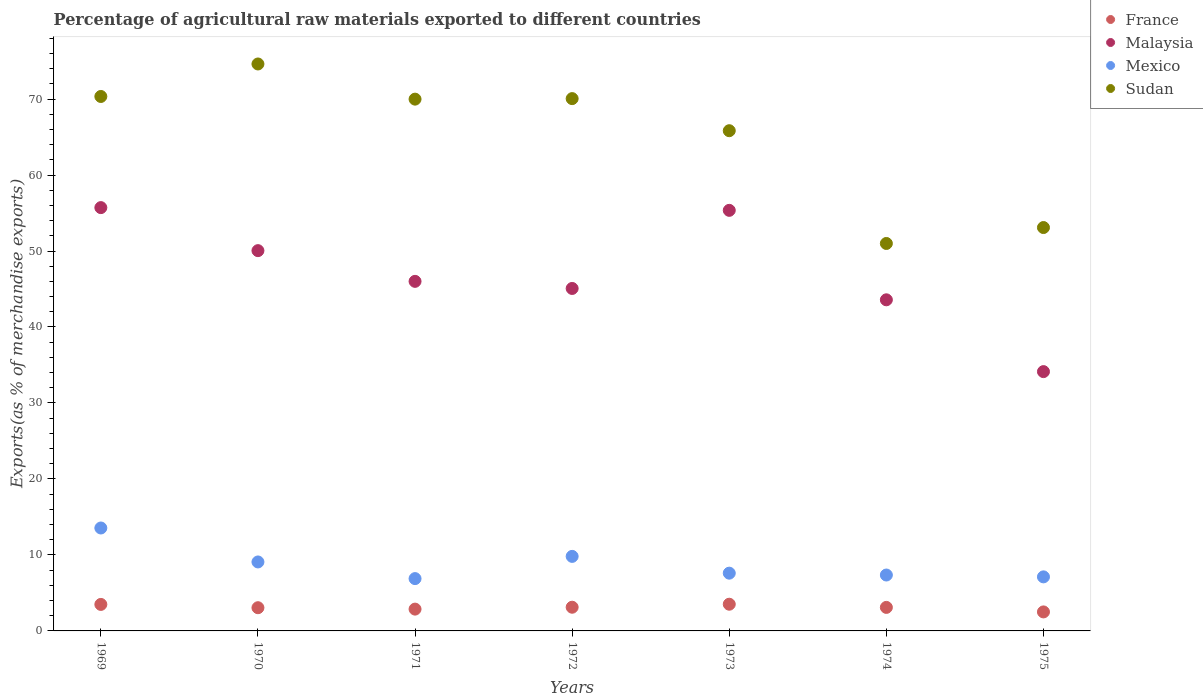How many different coloured dotlines are there?
Make the answer very short. 4. What is the percentage of exports to different countries in Mexico in 1975?
Offer a terse response. 7.11. Across all years, what is the maximum percentage of exports to different countries in France?
Keep it short and to the point. 3.51. Across all years, what is the minimum percentage of exports to different countries in Mexico?
Provide a short and direct response. 6.89. In which year was the percentage of exports to different countries in France maximum?
Provide a short and direct response. 1973. In which year was the percentage of exports to different countries in Malaysia minimum?
Make the answer very short. 1975. What is the total percentage of exports to different countries in France in the graph?
Your answer should be compact. 21.64. What is the difference between the percentage of exports to different countries in Sudan in 1969 and that in 1973?
Offer a very short reply. 4.5. What is the difference between the percentage of exports to different countries in Malaysia in 1971 and the percentage of exports to different countries in France in 1975?
Give a very brief answer. 43.5. What is the average percentage of exports to different countries in Mexico per year?
Offer a very short reply. 8.77. In the year 1969, what is the difference between the percentage of exports to different countries in France and percentage of exports to different countries in Malaysia?
Your answer should be very brief. -52.22. What is the ratio of the percentage of exports to different countries in Sudan in 1973 to that in 1975?
Offer a very short reply. 1.24. Is the percentage of exports to different countries in Mexico in 1970 less than that in 1975?
Provide a short and direct response. No. Is the difference between the percentage of exports to different countries in France in 1970 and 1973 greater than the difference between the percentage of exports to different countries in Malaysia in 1970 and 1973?
Offer a terse response. Yes. What is the difference between the highest and the second highest percentage of exports to different countries in Mexico?
Your answer should be compact. 3.74. What is the difference between the highest and the lowest percentage of exports to different countries in Malaysia?
Your answer should be very brief. 21.58. In how many years, is the percentage of exports to different countries in Sudan greater than the average percentage of exports to different countries in Sudan taken over all years?
Provide a short and direct response. 5. Is the sum of the percentage of exports to different countries in Mexico in 1969 and 1975 greater than the maximum percentage of exports to different countries in Sudan across all years?
Your response must be concise. No. Is the percentage of exports to different countries in Malaysia strictly greater than the percentage of exports to different countries in France over the years?
Provide a short and direct response. Yes. How many dotlines are there?
Give a very brief answer. 4. How many years are there in the graph?
Ensure brevity in your answer.  7. Does the graph contain any zero values?
Give a very brief answer. No. Does the graph contain grids?
Your response must be concise. No. What is the title of the graph?
Make the answer very short. Percentage of agricultural raw materials exported to different countries. Does "Timor-Leste" appear as one of the legend labels in the graph?
Make the answer very short. No. What is the label or title of the Y-axis?
Provide a short and direct response. Exports(as % of merchandise exports). What is the Exports(as % of merchandise exports) of France in 1969?
Your answer should be very brief. 3.49. What is the Exports(as % of merchandise exports) of Malaysia in 1969?
Provide a succinct answer. 55.71. What is the Exports(as % of merchandise exports) of Mexico in 1969?
Your answer should be very brief. 13.55. What is the Exports(as % of merchandise exports) in Sudan in 1969?
Make the answer very short. 70.34. What is the Exports(as % of merchandise exports) of France in 1970?
Provide a short and direct response. 3.05. What is the Exports(as % of merchandise exports) of Malaysia in 1970?
Offer a very short reply. 50.05. What is the Exports(as % of merchandise exports) of Mexico in 1970?
Your answer should be very brief. 9.08. What is the Exports(as % of merchandise exports) of Sudan in 1970?
Ensure brevity in your answer.  74.62. What is the Exports(as % of merchandise exports) in France in 1971?
Provide a short and direct response. 2.87. What is the Exports(as % of merchandise exports) in Malaysia in 1971?
Your response must be concise. 46.01. What is the Exports(as % of merchandise exports) of Mexico in 1971?
Keep it short and to the point. 6.89. What is the Exports(as % of merchandise exports) of Sudan in 1971?
Offer a very short reply. 69.99. What is the Exports(as % of merchandise exports) in France in 1972?
Provide a succinct answer. 3.12. What is the Exports(as % of merchandise exports) of Malaysia in 1972?
Your response must be concise. 45.07. What is the Exports(as % of merchandise exports) in Mexico in 1972?
Your answer should be compact. 9.81. What is the Exports(as % of merchandise exports) of Sudan in 1972?
Ensure brevity in your answer.  70.06. What is the Exports(as % of merchandise exports) of France in 1973?
Provide a short and direct response. 3.51. What is the Exports(as % of merchandise exports) in Malaysia in 1973?
Your response must be concise. 55.35. What is the Exports(as % of merchandise exports) of Mexico in 1973?
Ensure brevity in your answer.  7.6. What is the Exports(as % of merchandise exports) of Sudan in 1973?
Your response must be concise. 65.83. What is the Exports(as % of merchandise exports) of France in 1974?
Make the answer very short. 3.1. What is the Exports(as % of merchandise exports) of Malaysia in 1974?
Offer a terse response. 43.58. What is the Exports(as % of merchandise exports) in Mexico in 1974?
Give a very brief answer. 7.36. What is the Exports(as % of merchandise exports) of Sudan in 1974?
Your answer should be very brief. 50.99. What is the Exports(as % of merchandise exports) of France in 1975?
Your answer should be compact. 2.5. What is the Exports(as % of merchandise exports) of Malaysia in 1975?
Offer a very short reply. 34.13. What is the Exports(as % of merchandise exports) of Mexico in 1975?
Your answer should be very brief. 7.11. What is the Exports(as % of merchandise exports) in Sudan in 1975?
Your answer should be very brief. 53.09. Across all years, what is the maximum Exports(as % of merchandise exports) of France?
Ensure brevity in your answer.  3.51. Across all years, what is the maximum Exports(as % of merchandise exports) in Malaysia?
Provide a succinct answer. 55.71. Across all years, what is the maximum Exports(as % of merchandise exports) of Mexico?
Keep it short and to the point. 13.55. Across all years, what is the maximum Exports(as % of merchandise exports) of Sudan?
Ensure brevity in your answer.  74.62. Across all years, what is the minimum Exports(as % of merchandise exports) in France?
Make the answer very short. 2.5. Across all years, what is the minimum Exports(as % of merchandise exports) in Malaysia?
Give a very brief answer. 34.13. Across all years, what is the minimum Exports(as % of merchandise exports) of Mexico?
Your answer should be compact. 6.89. Across all years, what is the minimum Exports(as % of merchandise exports) in Sudan?
Ensure brevity in your answer.  50.99. What is the total Exports(as % of merchandise exports) of France in the graph?
Your response must be concise. 21.64. What is the total Exports(as % of merchandise exports) of Malaysia in the graph?
Provide a succinct answer. 329.89. What is the total Exports(as % of merchandise exports) in Mexico in the graph?
Provide a succinct answer. 61.39. What is the total Exports(as % of merchandise exports) in Sudan in the graph?
Provide a succinct answer. 454.91. What is the difference between the Exports(as % of merchandise exports) of France in 1969 and that in 1970?
Provide a succinct answer. 0.43. What is the difference between the Exports(as % of merchandise exports) in Malaysia in 1969 and that in 1970?
Your answer should be compact. 5.66. What is the difference between the Exports(as % of merchandise exports) in Mexico in 1969 and that in 1970?
Ensure brevity in your answer.  4.47. What is the difference between the Exports(as % of merchandise exports) in Sudan in 1969 and that in 1970?
Offer a very short reply. -4.28. What is the difference between the Exports(as % of merchandise exports) of France in 1969 and that in 1971?
Offer a terse response. 0.62. What is the difference between the Exports(as % of merchandise exports) in Malaysia in 1969 and that in 1971?
Your answer should be very brief. 9.71. What is the difference between the Exports(as % of merchandise exports) of Mexico in 1969 and that in 1971?
Offer a very short reply. 6.66. What is the difference between the Exports(as % of merchandise exports) in Sudan in 1969 and that in 1971?
Provide a short and direct response. 0.35. What is the difference between the Exports(as % of merchandise exports) in France in 1969 and that in 1972?
Your response must be concise. 0.37. What is the difference between the Exports(as % of merchandise exports) in Malaysia in 1969 and that in 1972?
Keep it short and to the point. 10.64. What is the difference between the Exports(as % of merchandise exports) in Mexico in 1969 and that in 1972?
Provide a succinct answer. 3.74. What is the difference between the Exports(as % of merchandise exports) in Sudan in 1969 and that in 1972?
Offer a very short reply. 0.28. What is the difference between the Exports(as % of merchandise exports) of France in 1969 and that in 1973?
Ensure brevity in your answer.  -0.03. What is the difference between the Exports(as % of merchandise exports) of Malaysia in 1969 and that in 1973?
Offer a very short reply. 0.36. What is the difference between the Exports(as % of merchandise exports) of Mexico in 1969 and that in 1973?
Make the answer very short. 5.94. What is the difference between the Exports(as % of merchandise exports) of Sudan in 1969 and that in 1973?
Offer a very short reply. 4.5. What is the difference between the Exports(as % of merchandise exports) in France in 1969 and that in 1974?
Give a very brief answer. 0.39. What is the difference between the Exports(as % of merchandise exports) of Malaysia in 1969 and that in 1974?
Offer a terse response. 12.13. What is the difference between the Exports(as % of merchandise exports) in Mexico in 1969 and that in 1974?
Make the answer very short. 6.19. What is the difference between the Exports(as % of merchandise exports) in Sudan in 1969 and that in 1974?
Offer a very short reply. 19.35. What is the difference between the Exports(as % of merchandise exports) of France in 1969 and that in 1975?
Offer a very short reply. 0.99. What is the difference between the Exports(as % of merchandise exports) of Malaysia in 1969 and that in 1975?
Offer a very short reply. 21.58. What is the difference between the Exports(as % of merchandise exports) in Mexico in 1969 and that in 1975?
Offer a terse response. 6.43. What is the difference between the Exports(as % of merchandise exports) in Sudan in 1969 and that in 1975?
Ensure brevity in your answer.  17.25. What is the difference between the Exports(as % of merchandise exports) of France in 1970 and that in 1971?
Your response must be concise. 0.18. What is the difference between the Exports(as % of merchandise exports) in Malaysia in 1970 and that in 1971?
Give a very brief answer. 4.04. What is the difference between the Exports(as % of merchandise exports) of Mexico in 1970 and that in 1971?
Provide a short and direct response. 2.19. What is the difference between the Exports(as % of merchandise exports) of Sudan in 1970 and that in 1971?
Give a very brief answer. 4.63. What is the difference between the Exports(as % of merchandise exports) of France in 1970 and that in 1972?
Provide a succinct answer. -0.06. What is the difference between the Exports(as % of merchandise exports) of Malaysia in 1970 and that in 1972?
Ensure brevity in your answer.  4.98. What is the difference between the Exports(as % of merchandise exports) in Mexico in 1970 and that in 1972?
Give a very brief answer. -0.73. What is the difference between the Exports(as % of merchandise exports) of Sudan in 1970 and that in 1972?
Give a very brief answer. 4.56. What is the difference between the Exports(as % of merchandise exports) in France in 1970 and that in 1973?
Offer a very short reply. -0.46. What is the difference between the Exports(as % of merchandise exports) in Malaysia in 1970 and that in 1973?
Your answer should be very brief. -5.3. What is the difference between the Exports(as % of merchandise exports) of Mexico in 1970 and that in 1973?
Offer a very short reply. 1.48. What is the difference between the Exports(as % of merchandise exports) in Sudan in 1970 and that in 1973?
Your answer should be very brief. 8.78. What is the difference between the Exports(as % of merchandise exports) in France in 1970 and that in 1974?
Ensure brevity in your answer.  -0.04. What is the difference between the Exports(as % of merchandise exports) of Malaysia in 1970 and that in 1974?
Your answer should be compact. 6.47. What is the difference between the Exports(as % of merchandise exports) of Mexico in 1970 and that in 1974?
Your response must be concise. 1.72. What is the difference between the Exports(as % of merchandise exports) of Sudan in 1970 and that in 1974?
Provide a succinct answer. 23.62. What is the difference between the Exports(as % of merchandise exports) of France in 1970 and that in 1975?
Your response must be concise. 0.55. What is the difference between the Exports(as % of merchandise exports) in Malaysia in 1970 and that in 1975?
Your answer should be compact. 15.92. What is the difference between the Exports(as % of merchandise exports) of Mexico in 1970 and that in 1975?
Provide a succinct answer. 1.96. What is the difference between the Exports(as % of merchandise exports) of Sudan in 1970 and that in 1975?
Offer a very short reply. 21.53. What is the difference between the Exports(as % of merchandise exports) in France in 1971 and that in 1972?
Your answer should be compact. -0.25. What is the difference between the Exports(as % of merchandise exports) of Malaysia in 1971 and that in 1972?
Ensure brevity in your answer.  0.93. What is the difference between the Exports(as % of merchandise exports) in Mexico in 1971 and that in 1972?
Provide a succinct answer. -2.92. What is the difference between the Exports(as % of merchandise exports) of Sudan in 1971 and that in 1972?
Offer a very short reply. -0.07. What is the difference between the Exports(as % of merchandise exports) of France in 1971 and that in 1973?
Ensure brevity in your answer.  -0.64. What is the difference between the Exports(as % of merchandise exports) in Malaysia in 1971 and that in 1973?
Offer a very short reply. -9.35. What is the difference between the Exports(as % of merchandise exports) of Mexico in 1971 and that in 1973?
Keep it short and to the point. -0.72. What is the difference between the Exports(as % of merchandise exports) in Sudan in 1971 and that in 1973?
Your answer should be compact. 4.15. What is the difference between the Exports(as % of merchandise exports) in France in 1971 and that in 1974?
Make the answer very short. -0.23. What is the difference between the Exports(as % of merchandise exports) of Malaysia in 1971 and that in 1974?
Your answer should be very brief. 2.43. What is the difference between the Exports(as % of merchandise exports) in Mexico in 1971 and that in 1974?
Your answer should be very brief. -0.47. What is the difference between the Exports(as % of merchandise exports) of Sudan in 1971 and that in 1974?
Your answer should be very brief. 19. What is the difference between the Exports(as % of merchandise exports) in France in 1971 and that in 1975?
Give a very brief answer. 0.37. What is the difference between the Exports(as % of merchandise exports) in Malaysia in 1971 and that in 1975?
Provide a succinct answer. 11.88. What is the difference between the Exports(as % of merchandise exports) in Mexico in 1971 and that in 1975?
Offer a terse response. -0.23. What is the difference between the Exports(as % of merchandise exports) in Sudan in 1971 and that in 1975?
Provide a succinct answer. 16.9. What is the difference between the Exports(as % of merchandise exports) of France in 1972 and that in 1973?
Your response must be concise. -0.4. What is the difference between the Exports(as % of merchandise exports) of Malaysia in 1972 and that in 1973?
Give a very brief answer. -10.28. What is the difference between the Exports(as % of merchandise exports) of Mexico in 1972 and that in 1973?
Provide a succinct answer. 2.21. What is the difference between the Exports(as % of merchandise exports) in Sudan in 1972 and that in 1973?
Provide a succinct answer. 4.22. What is the difference between the Exports(as % of merchandise exports) in France in 1972 and that in 1974?
Ensure brevity in your answer.  0.02. What is the difference between the Exports(as % of merchandise exports) of Malaysia in 1972 and that in 1974?
Provide a short and direct response. 1.49. What is the difference between the Exports(as % of merchandise exports) in Mexico in 1972 and that in 1974?
Offer a terse response. 2.45. What is the difference between the Exports(as % of merchandise exports) of Sudan in 1972 and that in 1974?
Give a very brief answer. 19.06. What is the difference between the Exports(as % of merchandise exports) in France in 1972 and that in 1975?
Your response must be concise. 0.62. What is the difference between the Exports(as % of merchandise exports) of Malaysia in 1972 and that in 1975?
Your answer should be compact. 10.94. What is the difference between the Exports(as % of merchandise exports) of Mexico in 1972 and that in 1975?
Provide a succinct answer. 2.7. What is the difference between the Exports(as % of merchandise exports) of Sudan in 1972 and that in 1975?
Offer a very short reply. 16.97. What is the difference between the Exports(as % of merchandise exports) of France in 1973 and that in 1974?
Your answer should be very brief. 0.42. What is the difference between the Exports(as % of merchandise exports) in Malaysia in 1973 and that in 1974?
Your answer should be very brief. 11.77. What is the difference between the Exports(as % of merchandise exports) of Mexico in 1973 and that in 1974?
Your response must be concise. 0.24. What is the difference between the Exports(as % of merchandise exports) in Sudan in 1973 and that in 1974?
Ensure brevity in your answer.  14.84. What is the difference between the Exports(as % of merchandise exports) of France in 1973 and that in 1975?
Keep it short and to the point. 1.01. What is the difference between the Exports(as % of merchandise exports) in Malaysia in 1973 and that in 1975?
Offer a very short reply. 21.23. What is the difference between the Exports(as % of merchandise exports) in Mexico in 1973 and that in 1975?
Keep it short and to the point. 0.49. What is the difference between the Exports(as % of merchandise exports) of Sudan in 1973 and that in 1975?
Ensure brevity in your answer.  12.75. What is the difference between the Exports(as % of merchandise exports) of France in 1974 and that in 1975?
Make the answer very short. 0.59. What is the difference between the Exports(as % of merchandise exports) in Malaysia in 1974 and that in 1975?
Offer a very short reply. 9.45. What is the difference between the Exports(as % of merchandise exports) of Mexico in 1974 and that in 1975?
Offer a very short reply. 0.24. What is the difference between the Exports(as % of merchandise exports) in Sudan in 1974 and that in 1975?
Give a very brief answer. -2.1. What is the difference between the Exports(as % of merchandise exports) of France in 1969 and the Exports(as % of merchandise exports) of Malaysia in 1970?
Ensure brevity in your answer.  -46.56. What is the difference between the Exports(as % of merchandise exports) of France in 1969 and the Exports(as % of merchandise exports) of Mexico in 1970?
Offer a very short reply. -5.59. What is the difference between the Exports(as % of merchandise exports) of France in 1969 and the Exports(as % of merchandise exports) of Sudan in 1970?
Give a very brief answer. -71.13. What is the difference between the Exports(as % of merchandise exports) of Malaysia in 1969 and the Exports(as % of merchandise exports) of Mexico in 1970?
Offer a very short reply. 46.63. What is the difference between the Exports(as % of merchandise exports) of Malaysia in 1969 and the Exports(as % of merchandise exports) of Sudan in 1970?
Give a very brief answer. -18.9. What is the difference between the Exports(as % of merchandise exports) in Mexico in 1969 and the Exports(as % of merchandise exports) in Sudan in 1970?
Give a very brief answer. -61.07. What is the difference between the Exports(as % of merchandise exports) in France in 1969 and the Exports(as % of merchandise exports) in Malaysia in 1971?
Offer a terse response. -42.52. What is the difference between the Exports(as % of merchandise exports) of France in 1969 and the Exports(as % of merchandise exports) of Mexico in 1971?
Give a very brief answer. -3.4. What is the difference between the Exports(as % of merchandise exports) of France in 1969 and the Exports(as % of merchandise exports) of Sudan in 1971?
Your response must be concise. -66.5. What is the difference between the Exports(as % of merchandise exports) in Malaysia in 1969 and the Exports(as % of merchandise exports) in Mexico in 1971?
Provide a succinct answer. 48.83. What is the difference between the Exports(as % of merchandise exports) in Malaysia in 1969 and the Exports(as % of merchandise exports) in Sudan in 1971?
Ensure brevity in your answer.  -14.28. What is the difference between the Exports(as % of merchandise exports) of Mexico in 1969 and the Exports(as % of merchandise exports) of Sudan in 1971?
Offer a terse response. -56.44. What is the difference between the Exports(as % of merchandise exports) in France in 1969 and the Exports(as % of merchandise exports) in Malaysia in 1972?
Offer a very short reply. -41.58. What is the difference between the Exports(as % of merchandise exports) of France in 1969 and the Exports(as % of merchandise exports) of Mexico in 1972?
Offer a terse response. -6.32. What is the difference between the Exports(as % of merchandise exports) of France in 1969 and the Exports(as % of merchandise exports) of Sudan in 1972?
Your answer should be compact. -66.57. What is the difference between the Exports(as % of merchandise exports) of Malaysia in 1969 and the Exports(as % of merchandise exports) of Mexico in 1972?
Offer a very short reply. 45.9. What is the difference between the Exports(as % of merchandise exports) in Malaysia in 1969 and the Exports(as % of merchandise exports) in Sudan in 1972?
Offer a very short reply. -14.35. What is the difference between the Exports(as % of merchandise exports) in Mexico in 1969 and the Exports(as % of merchandise exports) in Sudan in 1972?
Keep it short and to the point. -56.51. What is the difference between the Exports(as % of merchandise exports) of France in 1969 and the Exports(as % of merchandise exports) of Malaysia in 1973?
Keep it short and to the point. -51.86. What is the difference between the Exports(as % of merchandise exports) in France in 1969 and the Exports(as % of merchandise exports) in Mexico in 1973?
Your answer should be very brief. -4.11. What is the difference between the Exports(as % of merchandise exports) of France in 1969 and the Exports(as % of merchandise exports) of Sudan in 1973?
Provide a succinct answer. -62.35. What is the difference between the Exports(as % of merchandise exports) of Malaysia in 1969 and the Exports(as % of merchandise exports) of Mexico in 1973?
Provide a succinct answer. 48.11. What is the difference between the Exports(as % of merchandise exports) in Malaysia in 1969 and the Exports(as % of merchandise exports) in Sudan in 1973?
Offer a very short reply. -10.12. What is the difference between the Exports(as % of merchandise exports) of Mexico in 1969 and the Exports(as % of merchandise exports) of Sudan in 1973?
Keep it short and to the point. -52.29. What is the difference between the Exports(as % of merchandise exports) of France in 1969 and the Exports(as % of merchandise exports) of Malaysia in 1974?
Ensure brevity in your answer.  -40.09. What is the difference between the Exports(as % of merchandise exports) in France in 1969 and the Exports(as % of merchandise exports) in Mexico in 1974?
Make the answer very short. -3.87. What is the difference between the Exports(as % of merchandise exports) in France in 1969 and the Exports(as % of merchandise exports) in Sudan in 1974?
Provide a short and direct response. -47.5. What is the difference between the Exports(as % of merchandise exports) of Malaysia in 1969 and the Exports(as % of merchandise exports) of Mexico in 1974?
Your answer should be very brief. 48.35. What is the difference between the Exports(as % of merchandise exports) of Malaysia in 1969 and the Exports(as % of merchandise exports) of Sudan in 1974?
Provide a succinct answer. 4.72. What is the difference between the Exports(as % of merchandise exports) in Mexico in 1969 and the Exports(as % of merchandise exports) in Sudan in 1974?
Your response must be concise. -37.45. What is the difference between the Exports(as % of merchandise exports) of France in 1969 and the Exports(as % of merchandise exports) of Malaysia in 1975?
Keep it short and to the point. -30.64. What is the difference between the Exports(as % of merchandise exports) in France in 1969 and the Exports(as % of merchandise exports) in Mexico in 1975?
Your answer should be compact. -3.63. What is the difference between the Exports(as % of merchandise exports) of France in 1969 and the Exports(as % of merchandise exports) of Sudan in 1975?
Make the answer very short. -49.6. What is the difference between the Exports(as % of merchandise exports) of Malaysia in 1969 and the Exports(as % of merchandise exports) of Mexico in 1975?
Give a very brief answer. 48.6. What is the difference between the Exports(as % of merchandise exports) of Malaysia in 1969 and the Exports(as % of merchandise exports) of Sudan in 1975?
Your response must be concise. 2.62. What is the difference between the Exports(as % of merchandise exports) in Mexico in 1969 and the Exports(as % of merchandise exports) in Sudan in 1975?
Your answer should be very brief. -39.54. What is the difference between the Exports(as % of merchandise exports) in France in 1970 and the Exports(as % of merchandise exports) in Malaysia in 1971?
Provide a short and direct response. -42.95. What is the difference between the Exports(as % of merchandise exports) in France in 1970 and the Exports(as % of merchandise exports) in Mexico in 1971?
Your response must be concise. -3.83. What is the difference between the Exports(as % of merchandise exports) of France in 1970 and the Exports(as % of merchandise exports) of Sudan in 1971?
Your response must be concise. -66.93. What is the difference between the Exports(as % of merchandise exports) of Malaysia in 1970 and the Exports(as % of merchandise exports) of Mexico in 1971?
Provide a succinct answer. 43.16. What is the difference between the Exports(as % of merchandise exports) of Malaysia in 1970 and the Exports(as % of merchandise exports) of Sudan in 1971?
Offer a terse response. -19.94. What is the difference between the Exports(as % of merchandise exports) in Mexico in 1970 and the Exports(as % of merchandise exports) in Sudan in 1971?
Keep it short and to the point. -60.91. What is the difference between the Exports(as % of merchandise exports) in France in 1970 and the Exports(as % of merchandise exports) in Malaysia in 1972?
Keep it short and to the point. -42.02. What is the difference between the Exports(as % of merchandise exports) of France in 1970 and the Exports(as % of merchandise exports) of Mexico in 1972?
Make the answer very short. -6.75. What is the difference between the Exports(as % of merchandise exports) in France in 1970 and the Exports(as % of merchandise exports) in Sudan in 1972?
Provide a succinct answer. -67. What is the difference between the Exports(as % of merchandise exports) in Malaysia in 1970 and the Exports(as % of merchandise exports) in Mexico in 1972?
Provide a short and direct response. 40.24. What is the difference between the Exports(as % of merchandise exports) in Malaysia in 1970 and the Exports(as % of merchandise exports) in Sudan in 1972?
Offer a very short reply. -20.01. What is the difference between the Exports(as % of merchandise exports) of Mexico in 1970 and the Exports(as % of merchandise exports) of Sudan in 1972?
Ensure brevity in your answer.  -60.98. What is the difference between the Exports(as % of merchandise exports) in France in 1970 and the Exports(as % of merchandise exports) in Malaysia in 1973?
Provide a short and direct response. -52.3. What is the difference between the Exports(as % of merchandise exports) in France in 1970 and the Exports(as % of merchandise exports) in Mexico in 1973?
Your response must be concise. -4.55. What is the difference between the Exports(as % of merchandise exports) in France in 1970 and the Exports(as % of merchandise exports) in Sudan in 1973?
Provide a succinct answer. -62.78. What is the difference between the Exports(as % of merchandise exports) in Malaysia in 1970 and the Exports(as % of merchandise exports) in Mexico in 1973?
Keep it short and to the point. 42.45. What is the difference between the Exports(as % of merchandise exports) of Malaysia in 1970 and the Exports(as % of merchandise exports) of Sudan in 1973?
Provide a succinct answer. -15.79. What is the difference between the Exports(as % of merchandise exports) of Mexico in 1970 and the Exports(as % of merchandise exports) of Sudan in 1973?
Your answer should be compact. -56.76. What is the difference between the Exports(as % of merchandise exports) of France in 1970 and the Exports(as % of merchandise exports) of Malaysia in 1974?
Ensure brevity in your answer.  -40.52. What is the difference between the Exports(as % of merchandise exports) in France in 1970 and the Exports(as % of merchandise exports) in Mexico in 1974?
Your answer should be compact. -4.3. What is the difference between the Exports(as % of merchandise exports) of France in 1970 and the Exports(as % of merchandise exports) of Sudan in 1974?
Provide a short and direct response. -47.94. What is the difference between the Exports(as % of merchandise exports) in Malaysia in 1970 and the Exports(as % of merchandise exports) in Mexico in 1974?
Provide a succinct answer. 42.69. What is the difference between the Exports(as % of merchandise exports) in Malaysia in 1970 and the Exports(as % of merchandise exports) in Sudan in 1974?
Give a very brief answer. -0.94. What is the difference between the Exports(as % of merchandise exports) in Mexico in 1970 and the Exports(as % of merchandise exports) in Sudan in 1974?
Keep it short and to the point. -41.91. What is the difference between the Exports(as % of merchandise exports) of France in 1970 and the Exports(as % of merchandise exports) of Malaysia in 1975?
Offer a very short reply. -31.07. What is the difference between the Exports(as % of merchandise exports) of France in 1970 and the Exports(as % of merchandise exports) of Mexico in 1975?
Provide a succinct answer. -4.06. What is the difference between the Exports(as % of merchandise exports) in France in 1970 and the Exports(as % of merchandise exports) in Sudan in 1975?
Provide a short and direct response. -50.03. What is the difference between the Exports(as % of merchandise exports) in Malaysia in 1970 and the Exports(as % of merchandise exports) in Mexico in 1975?
Your response must be concise. 42.93. What is the difference between the Exports(as % of merchandise exports) in Malaysia in 1970 and the Exports(as % of merchandise exports) in Sudan in 1975?
Give a very brief answer. -3.04. What is the difference between the Exports(as % of merchandise exports) in Mexico in 1970 and the Exports(as % of merchandise exports) in Sudan in 1975?
Your answer should be very brief. -44.01. What is the difference between the Exports(as % of merchandise exports) of France in 1971 and the Exports(as % of merchandise exports) of Malaysia in 1972?
Your response must be concise. -42.2. What is the difference between the Exports(as % of merchandise exports) of France in 1971 and the Exports(as % of merchandise exports) of Mexico in 1972?
Ensure brevity in your answer.  -6.94. What is the difference between the Exports(as % of merchandise exports) of France in 1971 and the Exports(as % of merchandise exports) of Sudan in 1972?
Offer a terse response. -67.19. What is the difference between the Exports(as % of merchandise exports) in Malaysia in 1971 and the Exports(as % of merchandise exports) in Mexico in 1972?
Provide a succinct answer. 36.2. What is the difference between the Exports(as % of merchandise exports) in Malaysia in 1971 and the Exports(as % of merchandise exports) in Sudan in 1972?
Offer a very short reply. -24.05. What is the difference between the Exports(as % of merchandise exports) in Mexico in 1971 and the Exports(as % of merchandise exports) in Sudan in 1972?
Offer a very short reply. -63.17. What is the difference between the Exports(as % of merchandise exports) in France in 1971 and the Exports(as % of merchandise exports) in Malaysia in 1973?
Make the answer very short. -52.48. What is the difference between the Exports(as % of merchandise exports) in France in 1971 and the Exports(as % of merchandise exports) in Mexico in 1973?
Your response must be concise. -4.73. What is the difference between the Exports(as % of merchandise exports) in France in 1971 and the Exports(as % of merchandise exports) in Sudan in 1973?
Keep it short and to the point. -62.96. What is the difference between the Exports(as % of merchandise exports) in Malaysia in 1971 and the Exports(as % of merchandise exports) in Mexico in 1973?
Your answer should be very brief. 38.4. What is the difference between the Exports(as % of merchandise exports) in Malaysia in 1971 and the Exports(as % of merchandise exports) in Sudan in 1973?
Your answer should be very brief. -19.83. What is the difference between the Exports(as % of merchandise exports) in Mexico in 1971 and the Exports(as % of merchandise exports) in Sudan in 1973?
Your answer should be very brief. -58.95. What is the difference between the Exports(as % of merchandise exports) in France in 1971 and the Exports(as % of merchandise exports) in Malaysia in 1974?
Make the answer very short. -40.71. What is the difference between the Exports(as % of merchandise exports) in France in 1971 and the Exports(as % of merchandise exports) in Mexico in 1974?
Your response must be concise. -4.49. What is the difference between the Exports(as % of merchandise exports) of France in 1971 and the Exports(as % of merchandise exports) of Sudan in 1974?
Your response must be concise. -48.12. What is the difference between the Exports(as % of merchandise exports) in Malaysia in 1971 and the Exports(as % of merchandise exports) in Mexico in 1974?
Provide a short and direct response. 38.65. What is the difference between the Exports(as % of merchandise exports) of Malaysia in 1971 and the Exports(as % of merchandise exports) of Sudan in 1974?
Your answer should be very brief. -4.99. What is the difference between the Exports(as % of merchandise exports) in Mexico in 1971 and the Exports(as % of merchandise exports) in Sudan in 1974?
Make the answer very short. -44.11. What is the difference between the Exports(as % of merchandise exports) of France in 1971 and the Exports(as % of merchandise exports) of Malaysia in 1975?
Your response must be concise. -31.26. What is the difference between the Exports(as % of merchandise exports) in France in 1971 and the Exports(as % of merchandise exports) in Mexico in 1975?
Give a very brief answer. -4.24. What is the difference between the Exports(as % of merchandise exports) in France in 1971 and the Exports(as % of merchandise exports) in Sudan in 1975?
Give a very brief answer. -50.22. What is the difference between the Exports(as % of merchandise exports) of Malaysia in 1971 and the Exports(as % of merchandise exports) of Mexico in 1975?
Give a very brief answer. 38.89. What is the difference between the Exports(as % of merchandise exports) of Malaysia in 1971 and the Exports(as % of merchandise exports) of Sudan in 1975?
Offer a terse response. -7.08. What is the difference between the Exports(as % of merchandise exports) in Mexico in 1971 and the Exports(as % of merchandise exports) in Sudan in 1975?
Your answer should be very brief. -46.2. What is the difference between the Exports(as % of merchandise exports) in France in 1972 and the Exports(as % of merchandise exports) in Malaysia in 1973?
Give a very brief answer. -52.23. What is the difference between the Exports(as % of merchandise exports) in France in 1972 and the Exports(as % of merchandise exports) in Mexico in 1973?
Ensure brevity in your answer.  -4.48. What is the difference between the Exports(as % of merchandise exports) in France in 1972 and the Exports(as % of merchandise exports) in Sudan in 1973?
Ensure brevity in your answer.  -62.72. What is the difference between the Exports(as % of merchandise exports) in Malaysia in 1972 and the Exports(as % of merchandise exports) in Mexico in 1973?
Provide a short and direct response. 37.47. What is the difference between the Exports(as % of merchandise exports) in Malaysia in 1972 and the Exports(as % of merchandise exports) in Sudan in 1973?
Ensure brevity in your answer.  -20.76. What is the difference between the Exports(as % of merchandise exports) in Mexico in 1972 and the Exports(as % of merchandise exports) in Sudan in 1973?
Make the answer very short. -56.02. What is the difference between the Exports(as % of merchandise exports) of France in 1972 and the Exports(as % of merchandise exports) of Malaysia in 1974?
Ensure brevity in your answer.  -40.46. What is the difference between the Exports(as % of merchandise exports) in France in 1972 and the Exports(as % of merchandise exports) in Mexico in 1974?
Your response must be concise. -4.24. What is the difference between the Exports(as % of merchandise exports) in France in 1972 and the Exports(as % of merchandise exports) in Sudan in 1974?
Ensure brevity in your answer.  -47.87. What is the difference between the Exports(as % of merchandise exports) of Malaysia in 1972 and the Exports(as % of merchandise exports) of Mexico in 1974?
Give a very brief answer. 37.71. What is the difference between the Exports(as % of merchandise exports) in Malaysia in 1972 and the Exports(as % of merchandise exports) in Sudan in 1974?
Give a very brief answer. -5.92. What is the difference between the Exports(as % of merchandise exports) of Mexico in 1972 and the Exports(as % of merchandise exports) of Sudan in 1974?
Give a very brief answer. -41.18. What is the difference between the Exports(as % of merchandise exports) in France in 1972 and the Exports(as % of merchandise exports) in Malaysia in 1975?
Your answer should be very brief. -31.01. What is the difference between the Exports(as % of merchandise exports) in France in 1972 and the Exports(as % of merchandise exports) in Mexico in 1975?
Provide a succinct answer. -4. What is the difference between the Exports(as % of merchandise exports) of France in 1972 and the Exports(as % of merchandise exports) of Sudan in 1975?
Offer a very short reply. -49.97. What is the difference between the Exports(as % of merchandise exports) of Malaysia in 1972 and the Exports(as % of merchandise exports) of Mexico in 1975?
Your answer should be compact. 37.96. What is the difference between the Exports(as % of merchandise exports) in Malaysia in 1972 and the Exports(as % of merchandise exports) in Sudan in 1975?
Make the answer very short. -8.02. What is the difference between the Exports(as % of merchandise exports) of Mexico in 1972 and the Exports(as % of merchandise exports) of Sudan in 1975?
Give a very brief answer. -43.28. What is the difference between the Exports(as % of merchandise exports) in France in 1973 and the Exports(as % of merchandise exports) in Malaysia in 1974?
Provide a succinct answer. -40.06. What is the difference between the Exports(as % of merchandise exports) of France in 1973 and the Exports(as % of merchandise exports) of Mexico in 1974?
Your answer should be compact. -3.84. What is the difference between the Exports(as % of merchandise exports) in France in 1973 and the Exports(as % of merchandise exports) in Sudan in 1974?
Give a very brief answer. -47.48. What is the difference between the Exports(as % of merchandise exports) in Malaysia in 1973 and the Exports(as % of merchandise exports) in Mexico in 1974?
Keep it short and to the point. 48. What is the difference between the Exports(as % of merchandise exports) of Malaysia in 1973 and the Exports(as % of merchandise exports) of Sudan in 1974?
Provide a succinct answer. 4.36. What is the difference between the Exports(as % of merchandise exports) in Mexico in 1973 and the Exports(as % of merchandise exports) in Sudan in 1974?
Give a very brief answer. -43.39. What is the difference between the Exports(as % of merchandise exports) in France in 1973 and the Exports(as % of merchandise exports) in Malaysia in 1975?
Provide a short and direct response. -30.61. What is the difference between the Exports(as % of merchandise exports) in France in 1973 and the Exports(as % of merchandise exports) in Mexico in 1975?
Your answer should be very brief. -3.6. What is the difference between the Exports(as % of merchandise exports) of France in 1973 and the Exports(as % of merchandise exports) of Sudan in 1975?
Offer a very short reply. -49.57. What is the difference between the Exports(as % of merchandise exports) of Malaysia in 1973 and the Exports(as % of merchandise exports) of Mexico in 1975?
Your response must be concise. 48.24. What is the difference between the Exports(as % of merchandise exports) of Malaysia in 1973 and the Exports(as % of merchandise exports) of Sudan in 1975?
Make the answer very short. 2.26. What is the difference between the Exports(as % of merchandise exports) in Mexico in 1973 and the Exports(as % of merchandise exports) in Sudan in 1975?
Your answer should be very brief. -45.49. What is the difference between the Exports(as % of merchandise exports) of France in 1974 and the Exports(as % of merchandise exports) of Malaysia in 1975?
Your answer should be very brief. -31.03. What is the difference between the Exports(as % of merchandise exports) of France in 1974 and the Exports(as % of merchandise exports) of Mexico in 1975?
Provide a short and direct response. -4.02. What is the difference between the Exports(as % of merchandise exports) in France in 1974 and the Exports(as % of merchandise exports) in Sudan in 1975?
Offer a terse response. -49.99. What is the difference between the Exports(as % of merchandise exports) in Malaysia in 1974 and the Exports(as % of merchandise exports) in Mexico in 1975?
Your answer should be compact. 36.46. What is the difference between the Exports(as % of merchandise exports) in Malaysia in 1974 and the Exports(as % of merchandise exports) in Sudan in 1975?
Provide a short and direct response. -9.51. What is the difference between the Exports(as % of merchandise exports) of Mexico in 1974 and the Exports(as % of merchandise exports) of Sudan in 1975?
Keep it short and to the point. -45.73. What is the average Exports(as % of merchandise exports) of France per year?
Offer a terse response. 3.09. What is the average Exports(as % of merchandise exports) of Malaysia per year?
Make the answer very short. 47.13. What is the average Exports(as % of merchandise exports) in Mexico per year?
Offer a terse response. 8.77. What is the average Exports(as % of merchandise exports) of Sudan per year?
Give a very brief answer. 64.99. In the year 1969, what is the difference between the Exports(as % of merchandise exports) of France and Exports(as % of merchandise exports) of Malaysia?
Your answer should be compact. -52.22. In the year 1969, what is the difference between the Exports(as % of merchandise exports) of France and Exports(as % of merchandise exports) of Mexico?
Make the answer very short. -10.06. In the year 1969, what is the difference between the Exports(as % of merchandise exports) of France and Exports(as % of merchandise exports) of Sudan?
Your answer should be compact. -66.85. In the year 1969, what is the difference between the Exports(as % of merchandise exports) of Malaysia and Exports(as % of merchandise exports) of Mexico?
Your answer should be compact. 42.16. In the year 1969, what is the difference between the Exports(as % of merchandise exports) in Malaysia and Exports(as % of merchandise exports) in Sudan?
Provide a short and direct response. -14.63. In the year 1969, what is the difference between the Exports(as % of merchandise exports) in Mexico and Exports(as % of merchandise exports) in Sudan?
Provide a succinct answer. -56.79. In the year 1970, what is the difference between the Exports(as % of merchandise exports) in France and Exports(as % of merchandise exports) in Malaysia?
Your answer should be very brief. -46.99. In the year 1970, what is the difference between the Exports(as % of merchandise exports) in France and Exports(as % of merchandise exports) in Mexico?
Your answer should be very brief. -6.02. In the year 1970, what is the difference between the Exports(as % of merchandise exports) of France and Exports(as % of merchandise exports) of Sudan?
Offer a very short reply. -71.56. In the year 1970, what is the difference between the Exports(as % of merchandise exports) in Malaysia and Exports(as % of merchandise exports) in Mexico?
Your answer should be very brief. 40.97. In the year 1970, what is the difference between the Exports(as % of merchandise exports) of Malaysia and Exports(as % of merchandise exports) of Sudan?
Your response must be concise. -24.57. In the year 1970, what is the difference between the Exports(as % of merchandise exports) in Mexico and Exports(as % of merchandise exports) in Sudan?
Your response must be concise. -65.54. In the year 1971, what is the difference between the Exports(as % of merchandise exports) in France and Exports(as % of merchandise exports) in Malaysia?
Make the answer very short. -43.14. In the year 1971, what is the difference between the Exports(as % of merchandise exports) in France and Exports(as % of merchandise exports) in Mexico?
Give a very brief answer. -4.02. In the year 1971, what is the difference between the Exports(as % of merchandise exports) of France and Exports(as % of merchandise exports) of Sudan?
Your response must be concise. -67.12. In the year 1971, what is the difference between the Exports(as % of merchandise exports) of Malaysia and Exports(as % of merchandise exports) of Mexico?
Keep it short and to the point. 39.12. In the year 1971, what is the difference between the Exports(as % of merchandise exports) of Malaysia and Exports(as % of merchandise exports) of Sudan?
Offer a terse response. -23.98. In the year 1971, what is the difference between the Exports(as % of merchandise exports) of Mexico and Exports(as % of merchandise exports) of Sudan?
Offer a terse response. -63.1. In the year 1972, what is the difference between the Exports(as % of merchandise exports) in France and Exports(as % of merchandise exports) in Malaysia?
Provide a succinct answer. -41.95. In the year 1972, what is the difference between the Exports(as % of merchandise exports) in France and Exports(as % of merchandise exports) in Mexico?
Keep it short and to the point. -6.69. In the year 1972, what is the difference between the Exports(as % of merchandise exports) in France and Exports(as % of merchandise exports) in Sudan?
Ensure brevity in your answer.  -66.94. In the year 1972, what is the difference between the Exports(as % of merchandise exports) of Malaysia and Exports(as % of merchandise exports) of Mexico?
Offer a terse response. 35.26. In the year 1972, what is the difference between the Exports(as % of merchandise exports) of Malaysia and Exports(as % of merchandise exports) of Sudan?
Keep it short and to the point. -24.98. In the year 1972, what is the difference between the Exports(as % of merchandise exports) of Mexico and Exports(as % of merchandise exports) of Sudan?
Provide a short and direct response. -60.25. In the year 1973, what is the difference between the Exports(as % of merchandise exports) in France and Exports(as % of merchandise exports) in Malaysia?
Make the answer very short. -51.84. In the year 1973, what is the difference between the Exports(as % of merchandise exports) of France and Exports(as % of merchandise exports) of Mexico?
Provide a short and direct response. -4.09. In the year 1973, what is the difference between the Exports(as % of merchandise exports) in France and Exports(as % of merchandise exports) in Sudan?
Your answer should be compact. -62.32. In the year 1973, what is the difference between the Exports(as % of merchandise exports) of Malaysia and Exports(as % of merchandise exports) of Mexico?
Your response must be concise. 47.75. In the year 1973, what is the difference between the Exports(as % of merchandise exports) of Malaysia and Exports(as % of merchandise exports) of Sudan?
Your answer should be very brief. -10.48. In the year 1973, what is the difference between the Exports(as % of merchandise exports) in Mexico and Exports(as % of merchandise exports) in Sudan?
Provide a succinct answer. -58.23. In the year 1974, what is the difference between the Exports(as % of merchandise exports) of France and Exports(as % of merchandise exports) of Malaysia?
Provide a short and direct response. -40.48. In the year 1974, what is the difference between the Exports(as % of merchandise exports) of France and Exports(as % of merchandise exports) of Mexico?
Your response must be concise. -4.26. In the year 1974, what is the difference between the Exports(as % of merchandise exports) in France and Exports(as % of merchandise exports) in Sudan?
Give a very brief answer. -47.9. In the year 1974, what is the difference between the Exports(as % of merchandise exports) of Malaysia and Exports(as % of merchandise exports) of Mexico?
Your answer should be compact. 36.22. In the year 1974, what is the difference between the Exports(as % of merchandise exports) of Malaysia and Exports(as % of merchandise exports) of Sudan?
Give a very brief answer. -7.42. In the year 1974, what is the difference between the Exports(as % of merchandise exports) of Mexico and Exports(as % of merchandise exports) of Sudan?
Your response must be concise. -43.64. In the year 1975, what is the difference between the Exports(as % of merchandise exports) of France and Exports(as % of merchandise exports) of Malaysia?
Ensure brevity in your answer.  -31.63. In the year 1975, what is the difference between the Exports(as % of merchandise exports) of France and Exports(as % of merchandise exports) of Mexico?
Your response must be concise. -4.61. In the year 1975, what is the difference between the Exports(as % of merchandise exports) of France and Exports(as % of merchandise exports) of Sudan?
Provide a succinct answer. -50.59. In the year 1975, what is the difference between the Exports(as % of merchandise exports) of Malaysia and Exports(as % of merchandise exports) of Mexico?
Offer a terse response. 27.01. In the year 1975, what is the difference between the Exports(as % of merchandise exports) of Malaysia and Exports(as % of merchandise exports) of Sudan?
Offer a terse response. -18.96. In the year 1975, what is the difference between the Exports(as % of merchandise exports) in Mexico and Exports(as % of merchandise exports) in Sudan?
Keep it short and to the point. -45.97. What is the ratio of the Exports(as % of merchandise exports) of France in 1969 to that in 1970?
Offer a terse response. 1.14. What is the ratio of the Exports(as % of merchandise exports) of Malaysia in 1969 to that in 1970?
Provide a succinct answer. 1.11. What is the ratio of the Exports(as % of merchandise exports) of Mexico in 1969 to that in 1970?
Provide a short and direct response. 1.49. What is the ratio of the Exports(as % of merchandise exports) in Sudan in 1969 to that in 1970?
Provide a succinct answer. 0.94. What is the ratio of the Exports(as % of merchandise exports) in France in 1969 to that in 1971?
Give a very brief answer. 1.22. What is the ratio of the Exports(as % of merchandise exports) in Malaysia in 1969 to that in 1971?
Offer a terse response. 1.21. What is the ratio of the Exports(as % of merchandise exports) in Mexico in 1969 to that in 1971?
Make the answer very short. 1.97. What is the ratio of the Exports(as % of merchandise exports) of France in 1969 to that in 1972?
Make the answer very short. 1.12. What is the ratio of the Exports(as % of merchandise exports) of Malaysia in 1969 to that in 1972?
Provide a succinct answer. 1.24. What is the ratio of the Exports(as % of merchandise exports) in Mexico in 1969 to that in 1972?
Ensure brevity in your answer.  1.38. What is the ratio of the Exports(as % of merchandise exports) in Sudan in 1969 to that in 1972?
Offer a terse response. 1. What is the ratio of the Exports(as % of merchandise exports) of France in 1969 to that in 1973?
Your answer should be very brief. 0.99. What is the ratio of the Exports(as % of merchandise exports) in Mexico in 1969 to that in 1973?
Your answer should be compact. 1.78. What is the ratio of the Exports(as % of merchandise exports) of Sudan in 1969 to that in 1973?
Provide a short and direct response. 1.07. What is the ratio of the Exports(as % of merchandise exports) of France in 1969 to that in 1974?
Provide a succinct answer. 1.13. What is the ratio of the Exports(as % of merchandise exports) of Malaysia in 1969 to that in 1974?
Keep it short and to the point. 1.28. What is the ratio of the Exports(as % of merchandise exports) in Mexico in 1969 to that in 1974?
Provide a succinct answer. 1.84. What is the ratio of the Exports(as % of merchandise exports) of Sudan in 1969 to that in 1974?
Give a very brief answer. 1.38. What is the ratio of the Exports(as % of merchandise exports) of France in 1969 to that in 1975?
Keep it short and to the point. 1.39. What is the ratio of the Exports(as % of merchandise exports) of Malaysia in 1969 to that in 1975?
Provide a succinct answer. 1.63. What is the ratio of the Exports(as % of merchandise exports) in Mexico in 1969 to that in 1975?
Offer a very short reply. 1.9. What is the ratio of the Exports(as % of merchandise exports) of Sudan in 1969 to that in 1975?
Provide a succinct answer. 1.32. What is the ratio of the Exports(as % of merchandise exports) of France in 1970 to that in 1971?
Provide a succinct answer. 1.06. What is the ratio of the Exports(as % of merchandise exports) in Malaysia in 1970 to that in 1971?
Offer a terse response. 1.09. What is the ratio of the Exports(as % of merchandise exports) in Mexico in 1970 to that in 1971?
Ensure brevity in your answer.  1.32. What is the ratio of the Exports(as % of merchandise exports) in Sudan in 1970 to that in 1971?
Ensure brevity in your answer.  1.07. What is the ratio of the Exports(as % of merchandise exports) in France in 1970 to that in 1972?
Your answer should be compact. 0.98. What is the ratio of the Exports(as % of merchandise exports) in Malaysia in 1970 to that in 1972?
Your answer should be very brief. 1.11. What is the ratio of the Exports(as % of merchandise exports) of Mexico in 1970 to that in 1972?
Provide a short and direct response. 0.93. What is the ratio of the Exports(as % of merchandise exports) in Sudan in 1970 to that in 1972?
Your answer should be compact. 1.07. What is the ratio of the Exports(as % of merchandise exports) in France in 1970 to that in 1973?
Keep it short and to the point. 0.87. What is the ratio of the Exports(as % of merchandise exports) of Malaysia in 1970 to that in 1973?
Your answer should be very brief. 0.9. What is the ratio of the Exports(as % of merchandise exports) of Mexico in 1970 to that in 1973?
Make the answer very short. 1.19. What is the ratio of the Exports(as % of merchandise exports) in Sudan in 1970 to that in 1973?
Offer a terse response. 1.13. What is the ratio of the Exports(as % of merchandise exports) of France in 1970 to that in 1974?
Keep it short and to the point. 0.99. What is the ratio of the Exports(as % of merchandise exports) of Malaysia in 1970 to that in 1974?
Offer a terse response. 1.15. What is the ratio of the Exports(as % of merchandise exports) of Mexico in 1970 to that in 1974?
Give a very brief answer. 1.23. What is the ratio of the Exports(as % of merchandise exports) in Sudan in 1970 to that in 1974?
Make the answer very short. 1.46. What is the ratio of the Exports(as % of merchandise exports) of France in 1970 to that in 1975?
Keep it short and to the point. 1.22. What is the ratio of the Exports(as % of merchandise exports) of Malaysia in 1970 to that in 1975?
Make the answer very short. 1.47. What is the ratio of the Exports(as % of merchandise exports) in Mexico in 1970 to that in 1975?
Offer a very short reply. 1.28. What is the ratio of the Exports(as % of merchandise exports) of Sudan in 1970 to that in 1975?
Offer a very short reply. 1.41. What is the ratio of the Exports(as % of merchandise exports) in France in 1971 to that in 1972?
Your answer should be very brief. 0.92. What is the ratio of the Exports(as % of merchandise exports) of Malaysia in 1971 to that in 1972?
Offer a terse response. 1.02. What is the ratio of the Exports(as % of merchandise exports) in Mexico in 1971 to that in 1972?
Your response must be concise. 0.7. What is the ratio of the Exports(as % of merchandise exports) of France in 1971 to that in 1973?
Your answer should be very brief. 0.82. What is the ratio of the Exports(as % of merchandise exports) in Malaysia in 1971 to that in 1973?
Offer a terse response. 0.83. What is the ratio of the Exports(as % of merchandise exports) in Mexico in 1971 to that in 1973?
Provide a succinct answer. 0.91. What is the ratio of the Exports(as % of merchandise exports) of Sudan in 1971 to that in 1973?
Give a very brief answer. 1.06. What is the ratio of the Exports(as % of merchandise exports) of France in 1971 to that in 1974?
Your response must be concise. 0.93. What is the ratio of the Exports(as % of merchandise exports) in Malaysia in 1971 to that in 1974?
Your response must be concise. 1.06. What is the ratio of the Exports(as % of merchandise exports) in Mexico in 1971 to that in 1974?
Keep it short and to the point. 0.94. What is the ratio of the Exports(as % of merchandise exports) of Sudan in 1971 to that in 1974?
Make the answer very short. 1.37. What is the ratio of the Exports(as % of merchandise exports) in France in 1971 to that in 1975?
Your response must be concise. 1.15. What is the ratio of the Exports(as % of merchandise exports) in Malaysia in 1971 to that in 1975?
Offer a very short reply. 1.35. What is the ratio of the Exports(as % of merchandise exports) of Mexico in 1971 to that in 1975?
Keep it short and to the point. 0.97. What is the ratio of the Exports(as % of merchandise exports) in Sudan in 1971 to that in 1975?
Keep it short and to the point. 1.32. What is the ratio of the Exports(as % of merchandise exports) of France in 1972 to that in 1973?
Make the answer very short. 0.89. What is the ratio of the Exports(as % of merchandise exports) in Malaysia in 1972 to that in 1973?
Your response must be concise. 0.81. What is the ratio of the Exports(as % of merchandise exports) of Mexico in 1972 to that in 1973?
Offer a very short reply. 1.29. What is the ratio of the Exports(as % of merchandise exports) of Sudan in 1972 to that in 1973?
Keep it short and to the point. 1.06. What is the ratio of the Exports(as % of merchandise exports) in France in 1972 to that in 1974?
Your answer should be compact. 1.01. What is the ratio of the Exports(as % of merchandise exports) in Malaysia in 1972 to that in 1974?
Your response must be concise. 1.03. What is the ratio of the Exports(as % of merchandise exports) in Mexico in 1972 to that in 1974?
Keep it short and to the point. 1.33. What is the ratio of the Exports(as % of merchandise exports) of Sudan in 1972 to that in 1974?
Offer a very short reply. 1.37. What is the ratio of the Exports(as % of merchandise exports) of France in 1972 to that in 1975?
Keep it short and to the point. 1.25. What is the ratio of the Exports(as % of merchandise exports) of Malaysia in 1972 to that in 1975?
Provide a short and direct response. 1.32. What is the ratio of the Exports(as % of merchandise exports) of Mexico in 1972 to that in 1975?
Your response must be concise. 1.38. What is the ratio of the Exports(as % of merchandise exports) of Sudan in 1972 to that in 1975?
Ensure brevity in your answer.  1.32. What is the ratio of the Exports(as % of merchandise exports) in France in 1973 to that in 1974?
Make the answer very short. 1.13. What is the ratio of the Exports(as % of merchandise exports) of Malaysia in 1973 to that in 1974?
Provide a succinct answer. 1.27. What is the ratio of the Exports(as % of merchandise exports) in Sudan in 1973 to that in 1974?
Provide a short and direct response. 1.29. What is the ratio of the Exports(as % of merchandise exports) in France in 1973 to that in 1975?
Offer a very short reply. 1.4. What is the ratio of the Exports(as % of merchandise exports) in Malaysia in 1973 to that in 1975?
Provide a succinct answer. 1.62. What is the ratio of the Exports(as % of merchandise exports) of Mexico in 1973 to that in 1975?
Give a very brief answer. 1.07. What is the ratio of the Exports(as % of merchandise exports) of Sudan in 1973 to that in 1975?
Offer a very short reply. 1.24. What is the ratio of the Exports(as % of merchandise exports) in France in 1974 to that in 1975?
Make the answer very short. 1.24. What is the ratio of the Exports(as % of merchandise exports) in Malaysia in 1974 to that in 1975?
Provide a short and direct response. 1.28. What is the ratio of the Exports(as % of merchandise exports) of Mexico in 1974 to that in 1975?
Give a very brief answer. 1.03. What is the ratio of the Exports(as % of merchandise exports) of Sudan in 1974 to that in 1975?
Your answer should be very brief. 0.96. What is the difference between the highest and the second highest Exports(as % of merchandise exports) in France?
Offer a terse response. 0.03. What is the difference between the highest and the second highest Exports(as % of merchandise exports) of Malaysia?
Keep it short and to the point. 0.36. What is the difference between the highest and the second highest Exports(as % of merchandise exports) in Mexico?
Provide a succinct answer. 3.74. What is the difference between the highest and the second highest Exports(as % of merchandise exports) in Sudan?
Give a very brief answer. 4.28. What is the difference between the highest and the lowest Exports(as % of merchandise exports) of France?
Make the answer very short. 1.01. What is the difference between the highest and the lowest Exports(as % of merchandise exports) in Malaysia?
Your response must be concise. 21.58. What is the difference between the highest and the lowest Exports(as % of merchandise exports) in Mexico?
Keep it short and to the point. 6.66. What is the difference between the highest and the lowest Exports(as % of merchandise exports) in Sudan?
Make the answer very short. 23.62. 